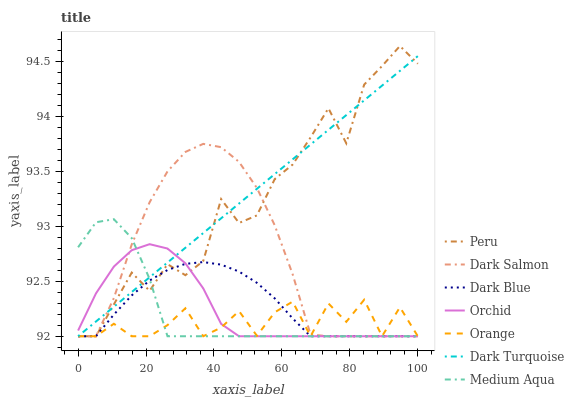Does Orange have the minimum area under the curve?
Answer yes or no. Yes. Does Dark Turquoise have the maximum area under the curve?
Answer yes or no. Yes. Does Dark Salmon have the minimum area under the curve?
Answer yes or no. No. Does Dark Salmon have the maximum area under the curve?
Answer yes or no. No. Is Dark Turquoise the smoothest?
Answer yes or no. Yes. Is Peru the roughest?
Answer yes or no. Yes. Is Dark Salmon the smoothest?
Answer yes or no. No. Is Dark Salmon the roughest?
Answer yes or no. No. Does Dark Turquoise have the lowest value?
Answer yes or no. Yes. Does Peru have the highest value?
Answer yes or no. Yes. Does Dark Salmon have the highest value?
Answer yes or no. No. Does Dark Salmon intersect Dark Blue?
Answer yes or no. Yes. Is Dark Salmon less than Dark Blue?
Answer yes or no. No. Is Dark Salmon greater than Dark Blue?
Answer yes or no. No. 